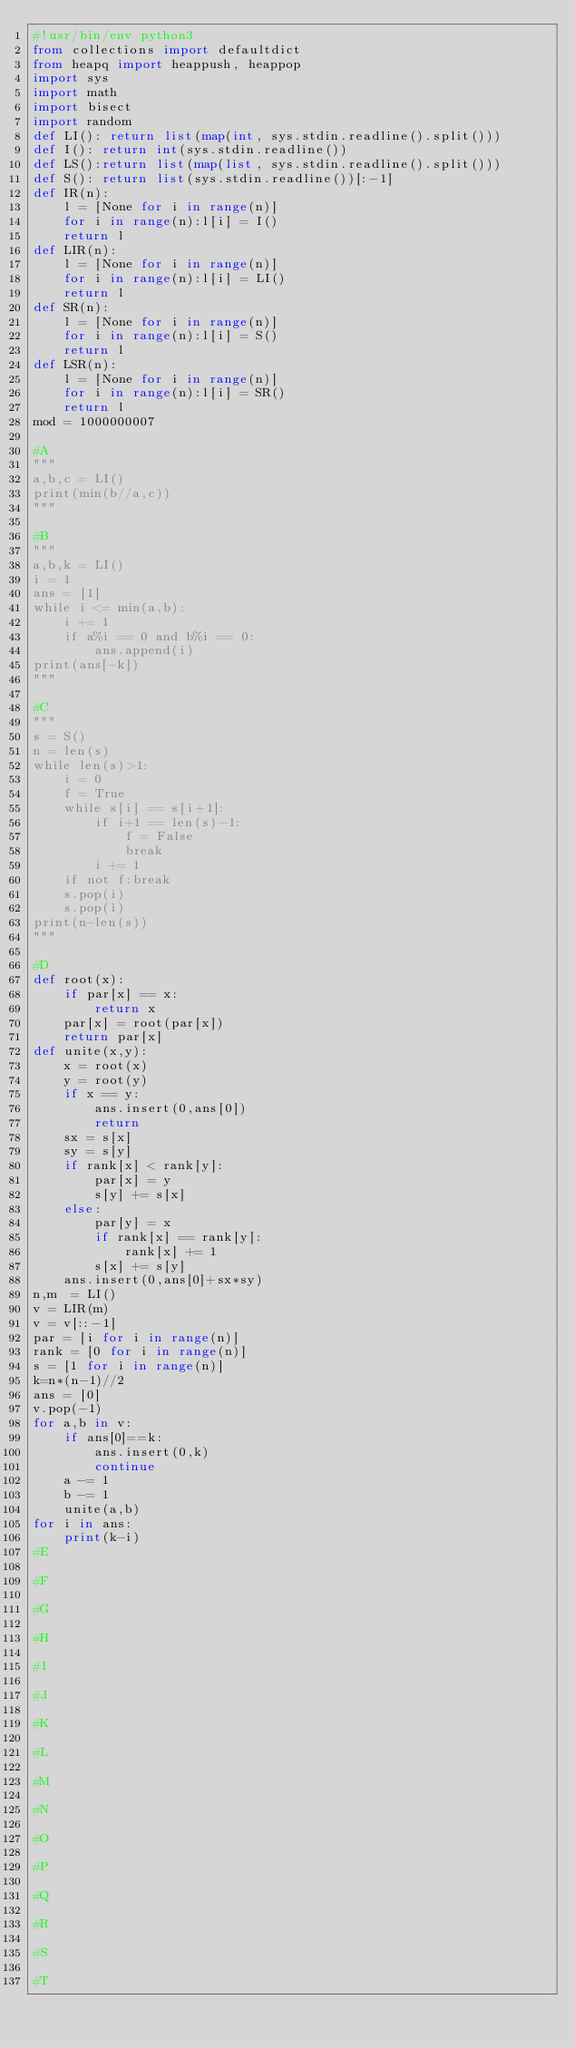Convert code to text. <code><loc_0><loc_0><loc_500><loc_500><_Python_>#!usr/bin/env python3
from collections import defaultdict
from heapq import heappush, heappop
import sys
import math
import bisect
import random
def LI(): return list(map(int, sys.stdin.readline().split()))
def I(): return int(sys.stdin.readline())
def LS():return list(map(list, sys.stdin.readline().split()))
def S(): return list(sys.stdin.readline())[:-1]
def IR(n):
    l = [None for i in range(n)]
    for i in range(n):l[i] = I()
    return l
def LIR(n):
    l = [None for i in range(n)]
    for i in range(n):l[i] = LI()
    return l
def SR(n):
    l = [None for i in range(n)]
    for i in range(n):l[i] = S()
    return l
def LSR(n):
    l = [None for i in range(n)]
    for i in range(n):l[i] = SR()
    return l
mod = 1000000007

#A
"""
a,b,c = LI()
print(min(b//a,c))
"""

#B
"""
a,b,k = LI()
i = 1
ans = [1]
while i <= min(a,b):
    i += 1
    if a%i == 0 and b%i == 0:
        ans.append(i)
print(ans[-k])
"""

#C
"""
s = S()
n = len(s)
while len(s)>1:
    i = 0
    f = True
    while s[i] == s[i+1]:
        if i+1 == len(s)-1:
            f = False
            break
        i += 1
    if not f:break
    s.pop(i)
    s.pop(i)
print(n-len(s))
"""

#D
def root(x):
    if par[x] == x:
        return x
    par[x] = root(par[x])
    return par[x]
def unite(x,y):
    x = root(x)
    y = root(y)
    if x == y:
        ans.insert(0,ans[0])
        return
    sx = s[x]
    sy = s[y]
    if rank[x] < rank[y]:
        par[x] = y
        s[y] += s[x]
    else:
        par[y] = x
        if rank[x] == rank[y]:
            rank[x] += 1
        s[x] += s[y]
    ans.insert(0,ans[0]+sx*sy)
n,m  = LI()
v = LIR(m)
v = v[::-1]
par = [i for i in range(n)]
rank = [0 for i in range(n)]
s = [1 for i in range(n)]
k=n*(n-1)//2
ans = [0]
v.pop(-1)
for a,b in v:
    if ans[0]==k:
        ans.insert(0,k)
        continue
    a -= 1
    b -= 1
    unite(a,b)
for i in ans:
    print(k-i)
#E

#F

#G

#H

#I

#J

#K

#L

#M

#N

#O

#P

#Q

#R

#S

#T
</code> 